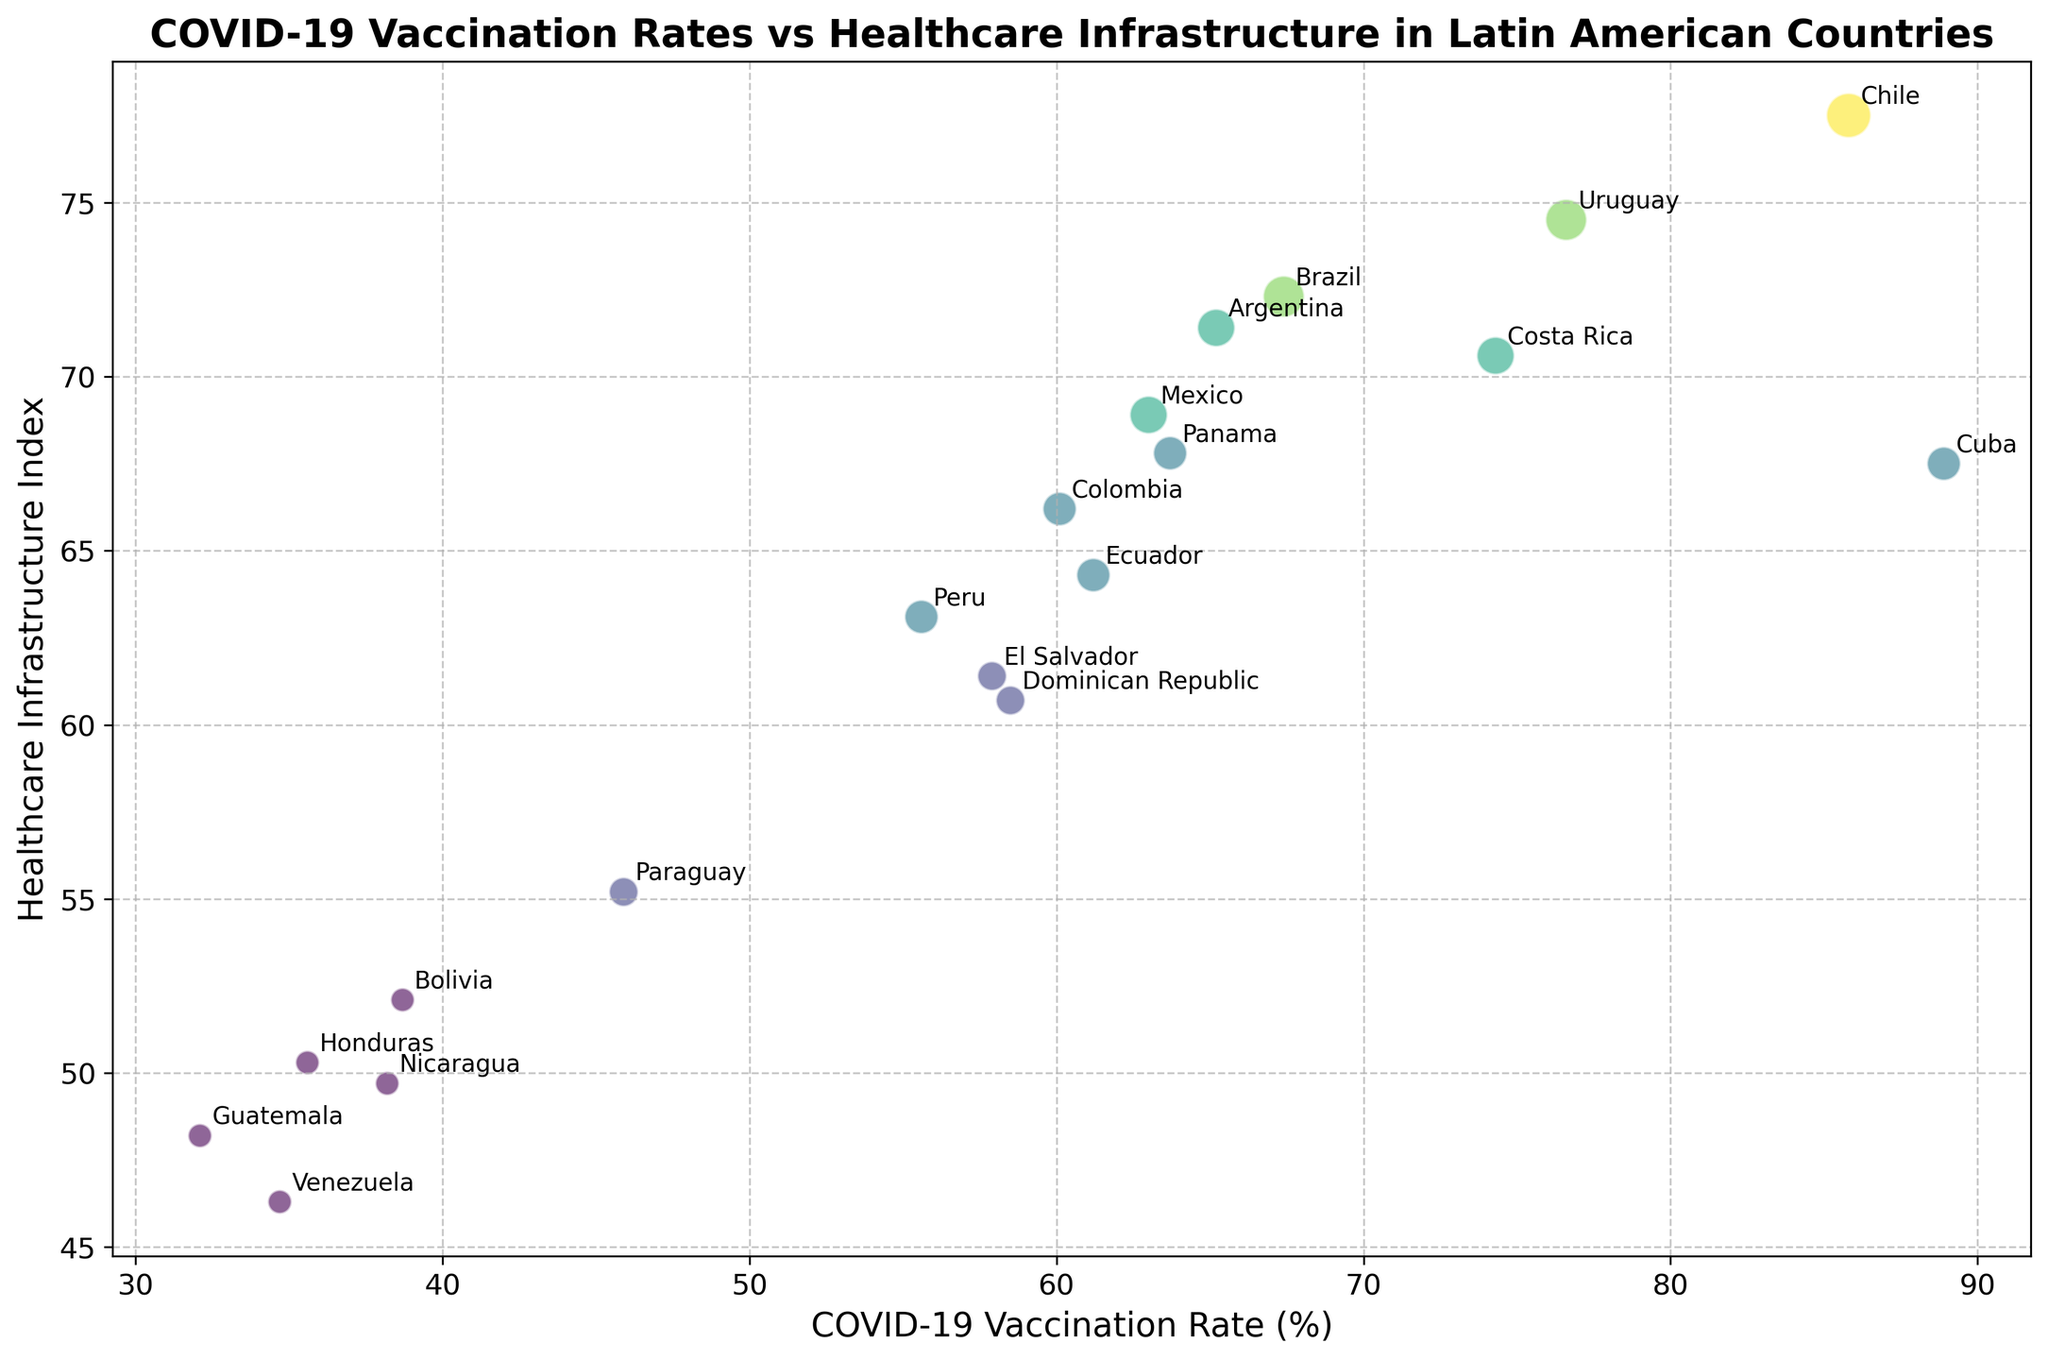What's the country with the highest COVID-19 Vaccination Rate (%)? Look for the country label positioned the farthest to the right on the x-axis, which represents the COVID-19 Vaccination Rate (%).
Answer: Cuba Which countries have a Healthcare Infrastructure Index greater than 70? Look for countries located above the horizontal line corresponding to a Healthcare Infrastructure Index of 70 on the y-axis.
Answer: Argentina, Brazil, Costa Rica, Uruguay, Chile Compare the COVID-19 Vaccination Rates of Mexico and Panama. Which one is higher? Locate both Mexico and Panama on the x-axis and compare their x-axis positions. The country further to the right has a higher vaccination rate.
Answer: Panama What is the approximate difference in COVID-19 Vaccination Rates between Cuba and Guatemala? Identify the positions of Cuba and Guatemala on the x-axis and subtract the value of Guatemala from Cuba's value.
Answer: Approximately 56.8% Which country has both high COVID-19 Vaccination Rate and high Healthcare Infrastructure Index? Look for countries located in the top-right quadrant of the chart.
Answer: Chile Between Colombia and Ecuador, which country has a better Healthcare Infrastructure Index? Locate both Colombia and Ecuador on the y-axis and compare their positions. The country higher up has a better infrastructure index.
Answer: Colombia Is there any country with a Bubble Size of 7? If so, what does it represent in terms of Healthcare Infrastructure? Look for the largest bubble on the plot and check its y-axis position to know its Healthcare Infrastructure Index.
Answer: Chile, Index = 77.5 How different are the Healthcare Infrastructure Indices of Argentina and Venezuela? Identify the positions of Argentina and Venezuela on the y-axis and subtract the value of Venezuela from Argentina's value.
Answer: Approximately 25.1 Which country has the smallest bubble and what does it imply? Find the smallest bubble on the plot; examine its location, and determine what country it represents and its implication in Healthcare Infrastructure.
Answer: Bolivia, Guatemala, Honduras, Nicaragua, Venezuela; implies minimal healthcare infrastructure What is the average COVID-19 Vaccination Rate (%) of Brazil, Argentina, and Uruguay? Take the COVID-19 Vaccination Rates of Brazil (67.4), Argentina (65.2), and Uruguay (76.6), sum them up and divide by 3 to find the average.
Answer: Approximately 69.7 